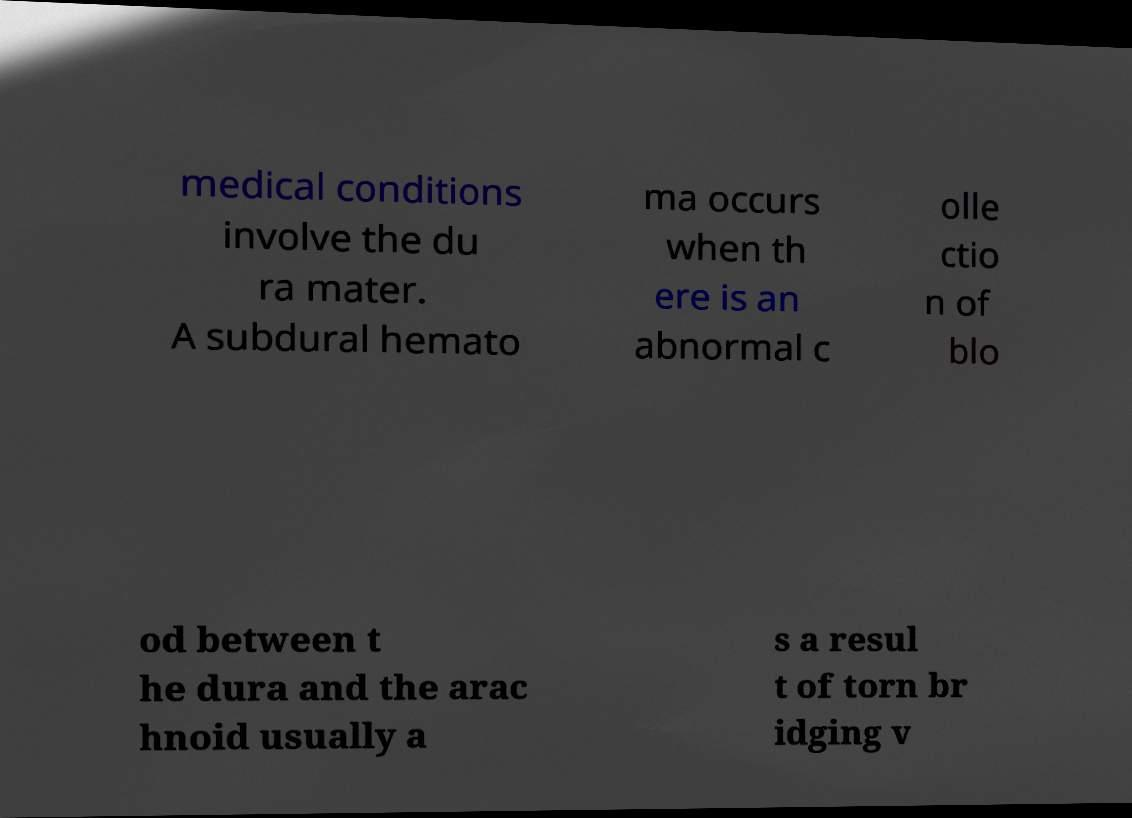There's text embedded in this image that I need extracted. Can you transcribe it verbatim? medical conditions involve the du ra mater. A subdural hemato ma occurs when th ere is an abnormal c olle ctio n of blo od between t he dura and the arac hnoid usually a s a resul t of torn br idging v 